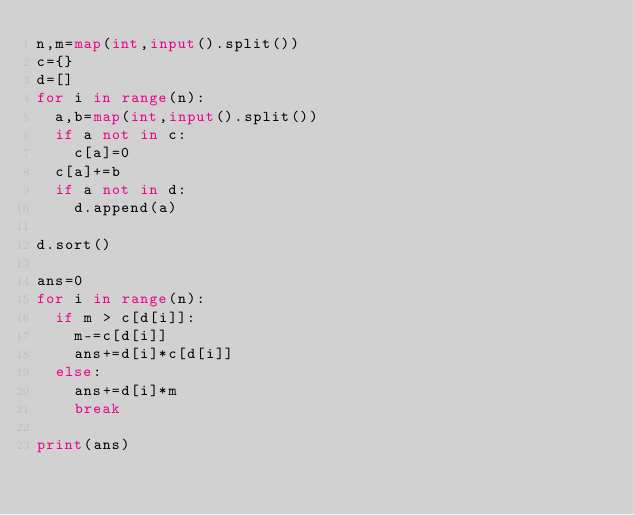<code> <loc_0><loc_0><loc_500><loc_500><_Python_>n,m=map(int,input().split())
c={}
d=[]
for i in range(n):
  a,b=map(int,input().split())
  if a not in c:
    c[a]=0
  c[a]+=b
  if a not in d:
    d.append(a)
  
d.sort()

ans=0
for i in range(n):
  if m > c[d[i]]:
    m-=c[d[i]]
    ans+=d[i]*c[d[i]]
  else:
    ans+=d[i]*m
    break
    
print(ans)

  </code> 